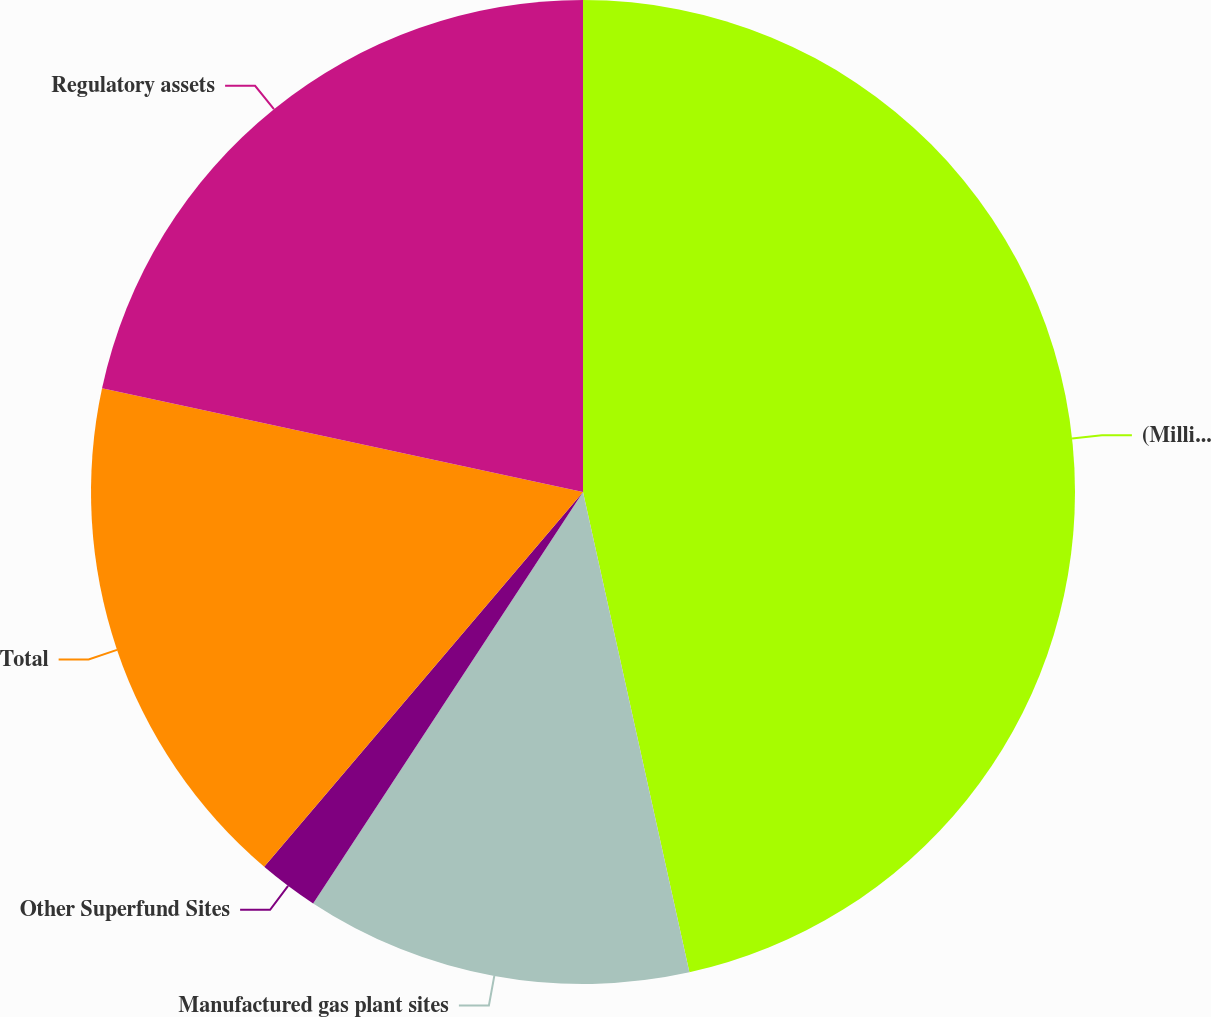<chart> <loc_0><loc_0><loc_500><loc_500><pie_chart><fcel>(Millions of Dollars)<fcel>Manufactured gas plant sites<fcel>Other Superfund Sites<fcel>Total<fcel>Regulatory assets<nl><fcel>46.53%<fcel>12.71%<fcel>1.98%<fcel>17.16%<fcel>21.62%<nl></chart> 